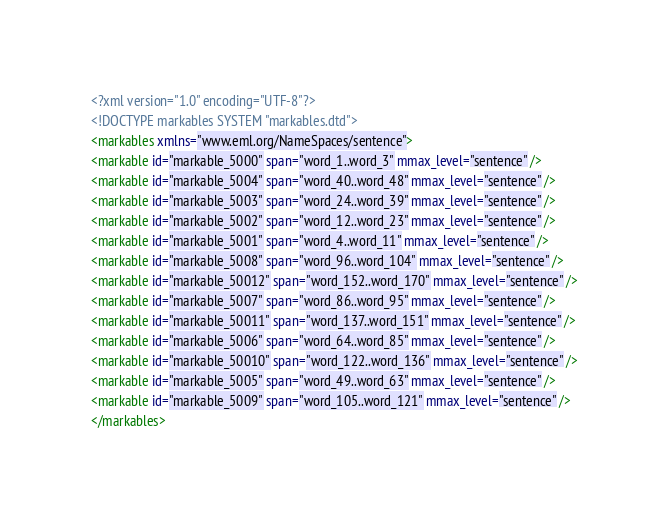Convert code to text. <code><loc_0><loc_0><loc_500><loc_500><_XML_><?xml version="1.0" encoding="UTF-8"?>
<!DOCTYPE markables SYSTEM "markables.dtd">
<markables xmlns="www.eml.org/NameSpaces/sentence">
<markable id="markable_5000" span="word_1..word_3" mmax_level="sentence" />
<markable id="markable_5004" span="word_40..word_48" mmax_level="sentence" />
<markable id="markable_5003" span="word_24..word_39" mmax_level="sentence" />
<markable id="markable_5002" span="word_12..word_23" mmax_level="sentence" />
<markable id="markable_5001" span="word_4..word_11" mmax_level="sentence" />
<markable id="markable_5008" span="word_96..word_104" mmax_level="sentence" />
<markable id="markable_50012" span="word_152..word_170" mmax_level="sentence" />
<markable id="markable_5007" span="word_86..word_95" mmax_level="sentence" />
<markable id="markable_50011" span="word_137..word_151" mmax_level="sentence" />
<markable id="markable_5006" span="word_64..word_85" mmax_level="sentence" />
<markable id="markable_50010" span="word_122..word_136" mmax_level="sentence" />
<markable id="markable_5005" span="word_49..word_63" mmax_level="sentence" />
<markable id="markable_5009" span="word_105..word_121" mmax_level="sentence" />
</markables></code> 